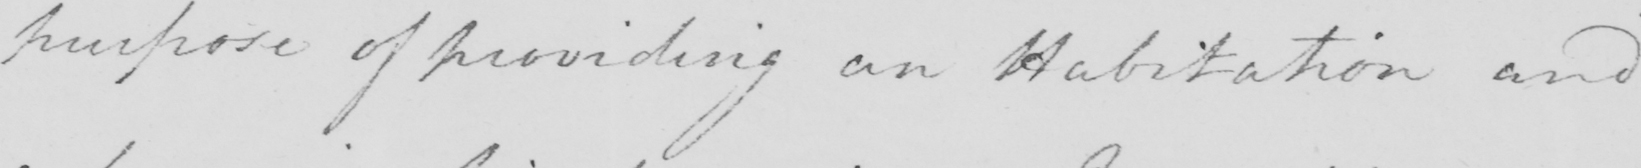What is written in this line of handwriting? purpose of providing an Habitation and 